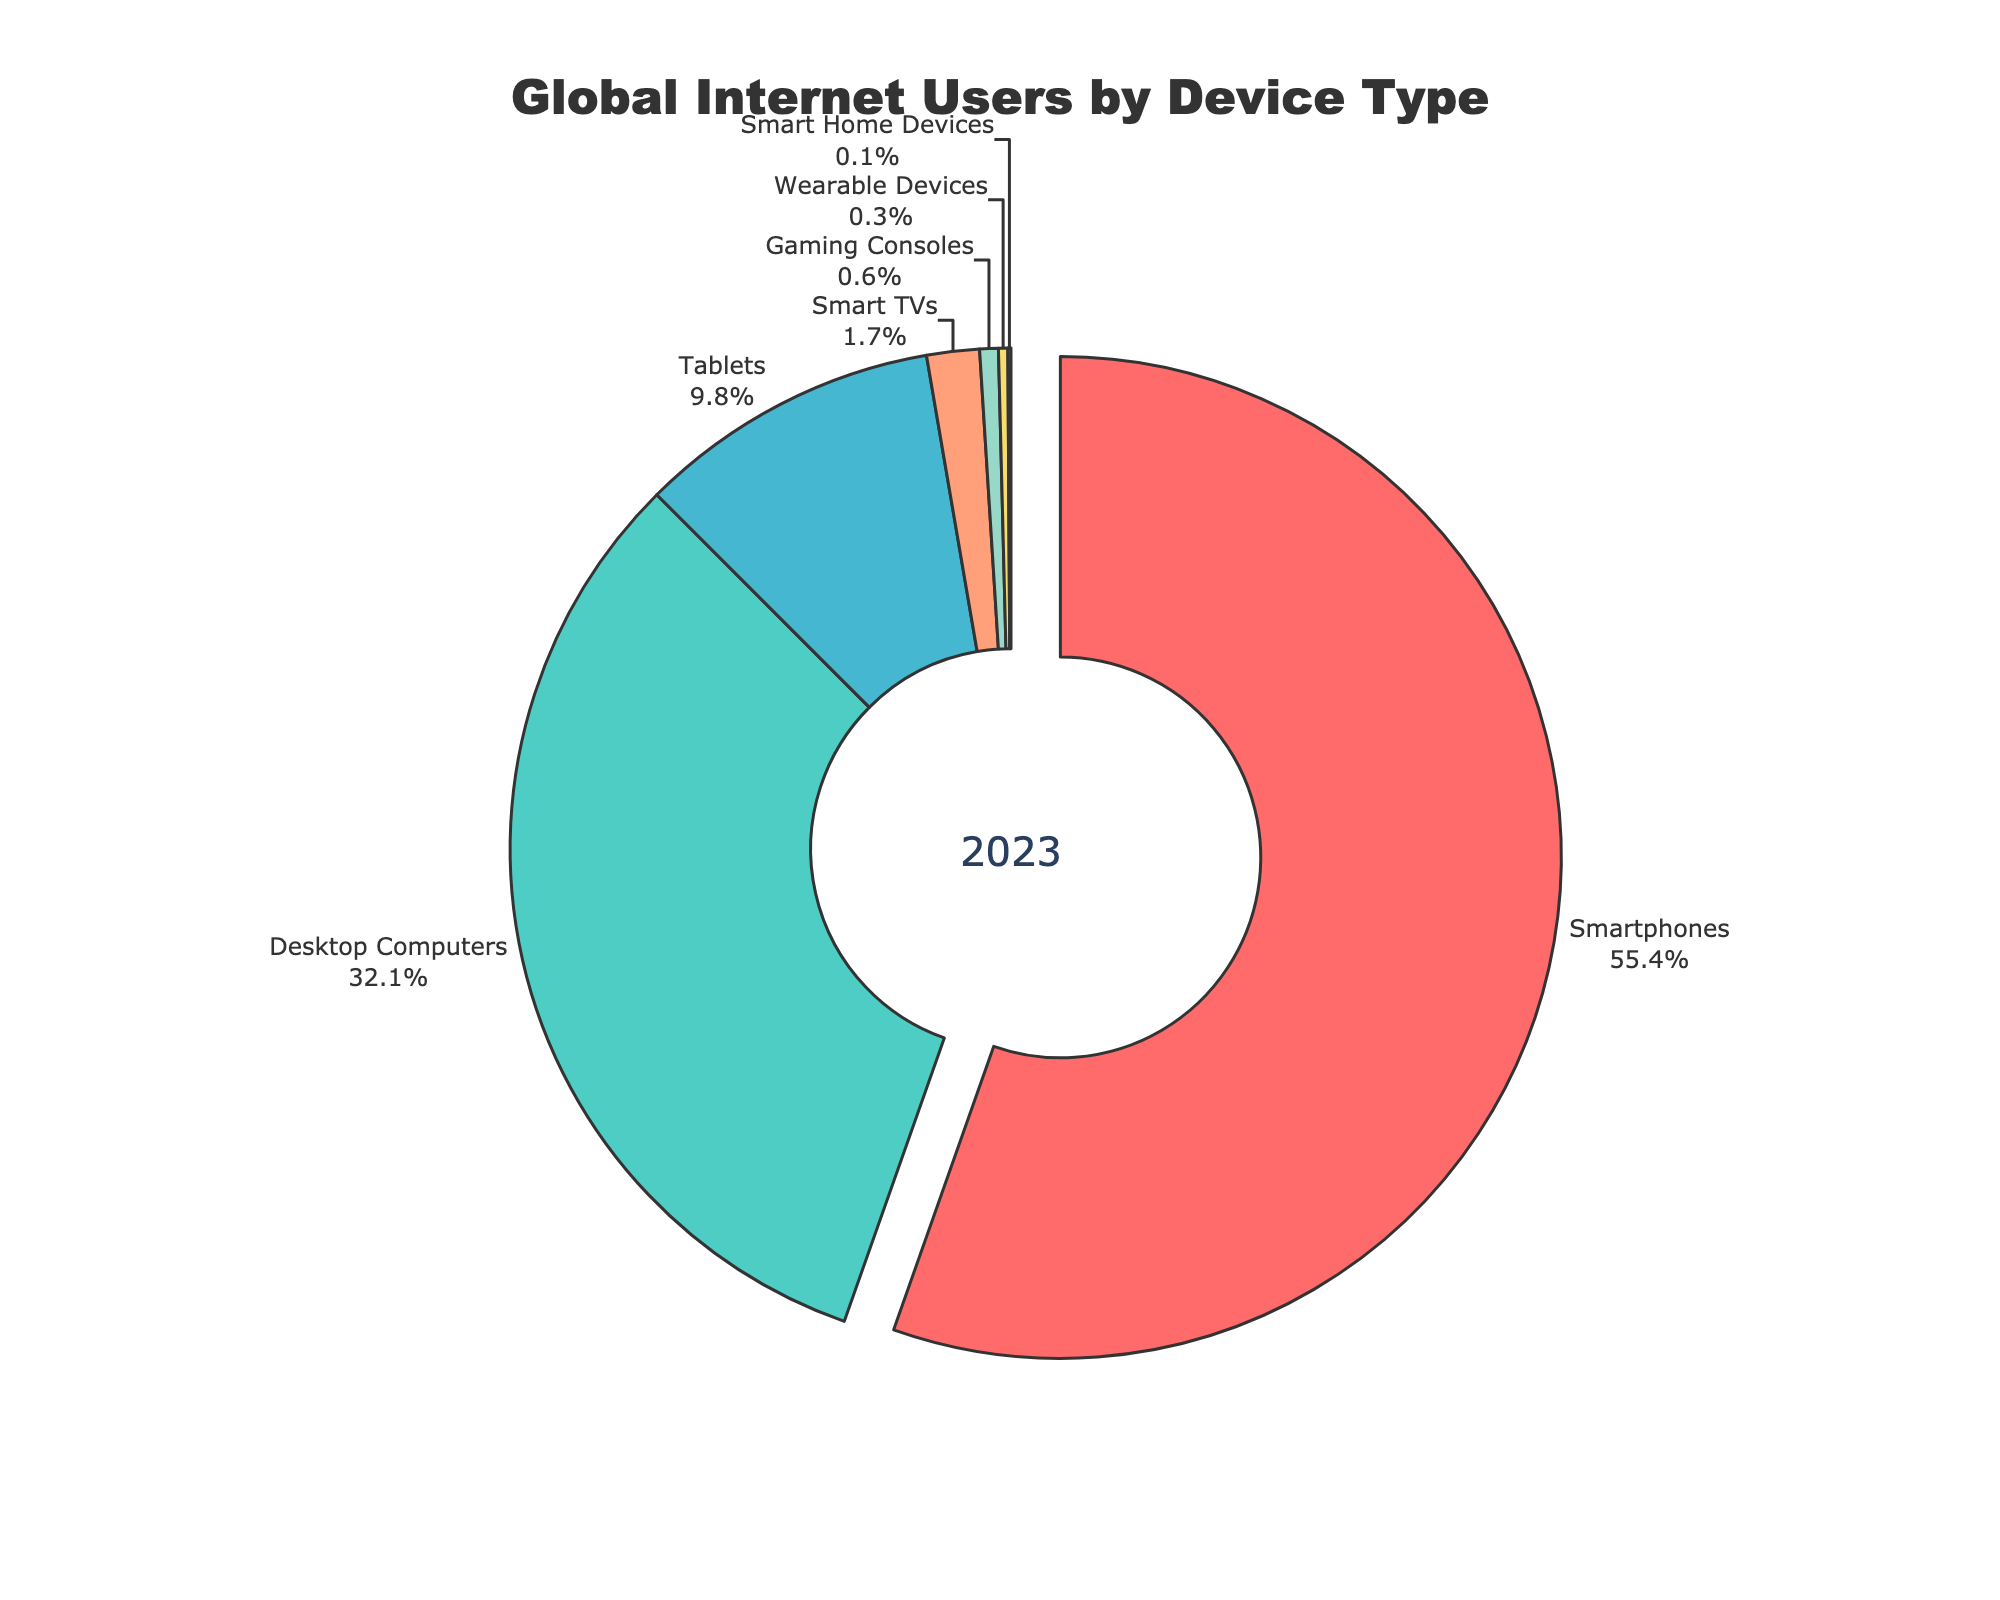Which device type has the largest share of global internet users? The figure shows a donut chart titled "Global Internet Users by Device Type". The device type with the largest share is depicted by the largest segment of the donut.
Answer: Smartphones What percentage of global internet users use tablets? The donut chart contains labels and percentages for each device type. The segment labeled "Tablets" shows a percentage value.
Answer: 9.8% How much greater is the percentage of smartphone users compared to desktop computer users? To find the difference, identify the percentages from the chart: Smartphones (55.4%) and Desktop Computers (32.1%), then subtract the latter from the former. 55.4% - 32.1% = 23.3%
Answer: 23.3% What is the combined percentage of global internet users who use Smart TVs, Gaming Consoles, Wearable Devices, and Smart Home Devices? Sum the percentages of these device types: Smart TVs (1.7%) + Gaming Consoles (0.6%) + Wearable Devices (0.3%) + Smart Home Devices (0.1%) = 2.7%
Answer: 2.7% Among the device types, which one has the smallest user percentage and what is that percentage? The smallest segment of the donut chart represents the device type with the smallest percentage. The label on this segment indicates the device type and its corresponding percentage.
Answer: Smart Home Devices, 0.1% Is the percentage of desktop computer users more than three times the percentage of tablet users? Check if 32.1% (Desktop Computers) is more than three times 9.8% (Tablets), 3 * 9.8% = 29.4%. Since 32.1% > 29.4%, the answer is yes.
Answer: Yes Which two device types have a combined percentage closest to 10%? Compare the combined percentages of different pairs of device types to find the pair closest to 10%. Wearable Devices (0.3%) + Tablets (9.8%) = 10.1%, which is closest.
Answer: Tablets and Wearable Devices How many times greater is the percentage of smartphone users compared to wearable device users? Divide the percentage of smartphone users (55.4%) by that of wearable device users (0.3%). 55.4 / 0.3 = 184.67
Answer: 184.67 What visual feature highlights the device type with the largest share? Identify the visual element from the chart that distinguishes this segment. The largest segment is slightly pulled out from the rest.
Answer: The largest segment is pulled out What percentage of global internet users use either desktop computers or tablets? Add the percentages of users for desktop computers (32.1%) and tablets (9.8%). 32.1% + 9.8% = 41.9%
Answer: 41.9% 